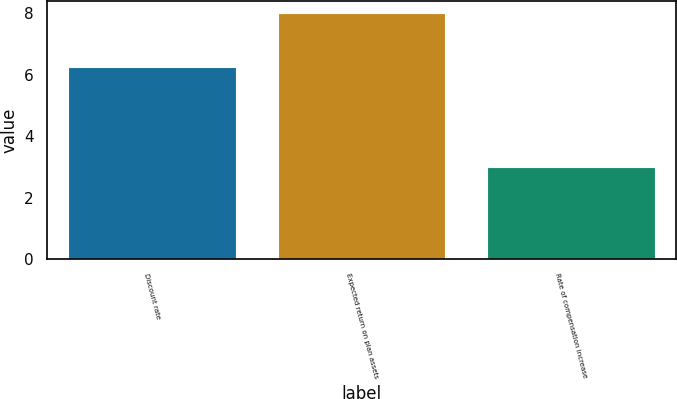<chart> <loc_0><loc_0><loc_500><loc_500><bar_chart><fcel>Discount rate<fcel>Expected return on plan assets<fcel>Rate of compensation increase<nl><fcel>6.25<fcel>8<fcel>3<nl></chart> 